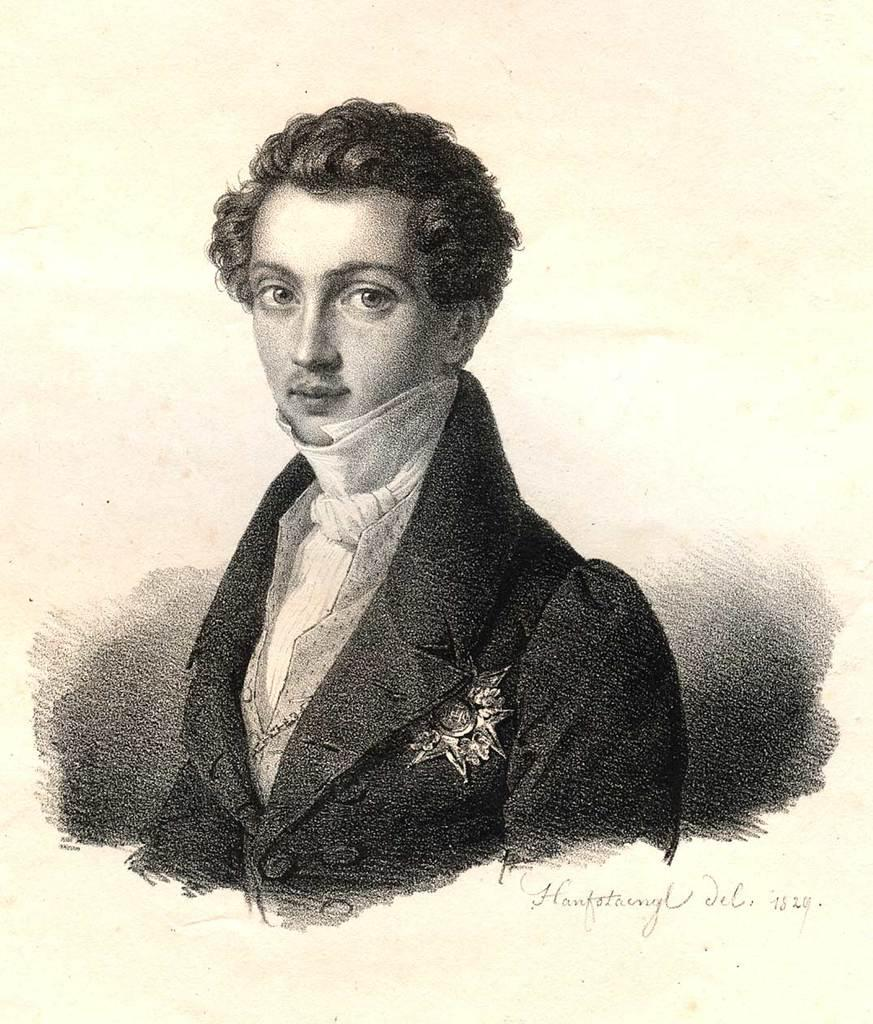What is: What is the main subject of the image? The main subject of the image is a photograph of a person. Is there any text present in the image? Yes, there is handwritten text in the image. What type of border is visible around the photograph in the image? There is no mention of a border around the photograph in the provided facts, so it cannot be determined from the image. 